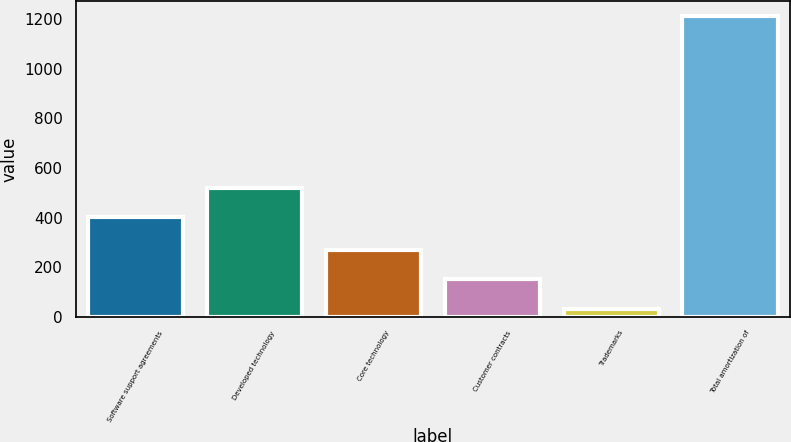<chart> <loc_0><loc_0><loc_500><loc_500><bar_chart><fcel>Software support agreements<fcel>Developed technology<fcel>Core technology<fcel>Customer contracts<fcel>Trademarks<fcel>Total amortization of<nl><fcel>402<fcel>520<fcel>268<fcel>150<fcel>32<fcel>1212<nl></chart> 